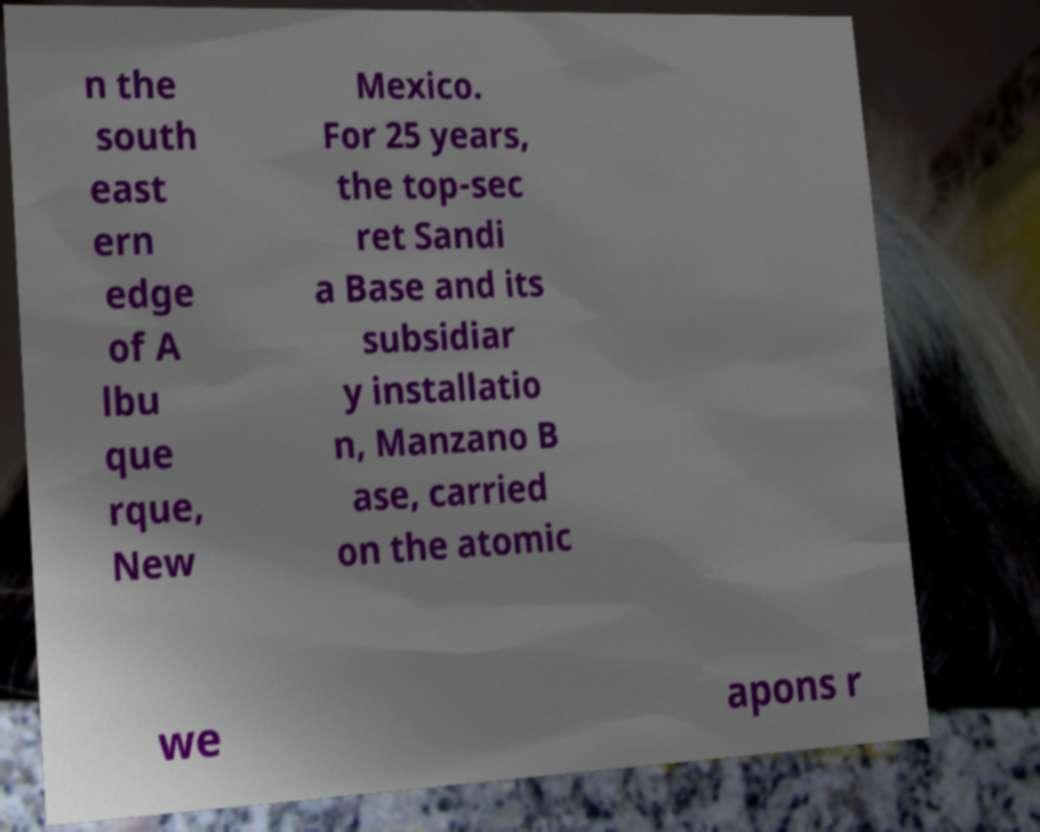What messages or text are displayed in this image? I need them in a readable, typed format. n the south east ern edge of A lbu que rque, New Mexico. For 25 years, the top-sec ret Sandi a Base and its subsidiar y installatio n, Manzano B ase, carried on the atomic we apons r 